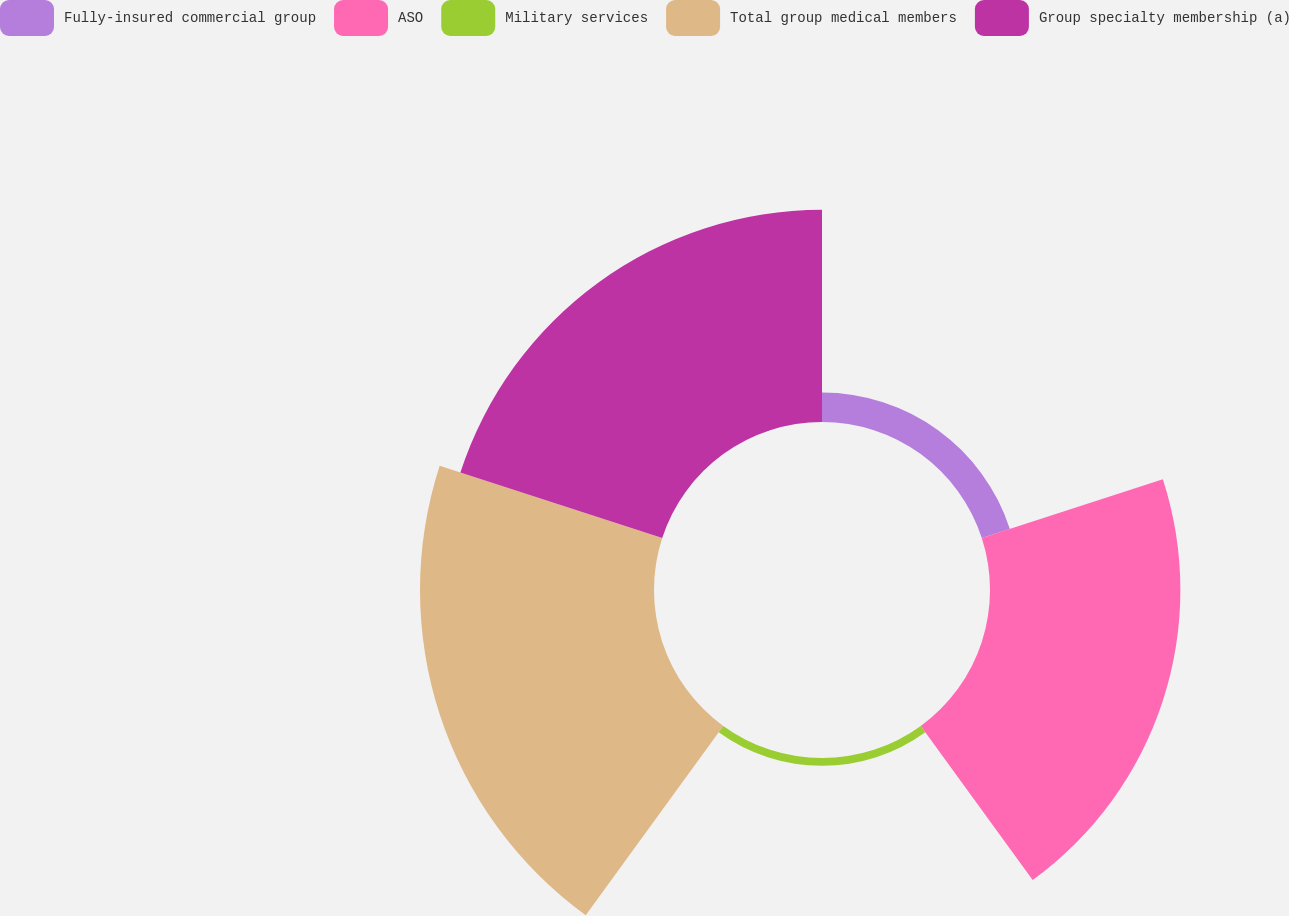Convert chart. <chart><loc_0><loc_0><loc_500><loc_500><pie_chart><fcel>Fully-insured commercial group<fcel>ASO<fcel>Military services<fcel>Total group medical members<fcel>Group specialty membership (a)<nl><fcel>4.38%<fcel>28.25%<fcel>1.15%<fcel>34.72%<fcel>31.49%<nl></chart> 